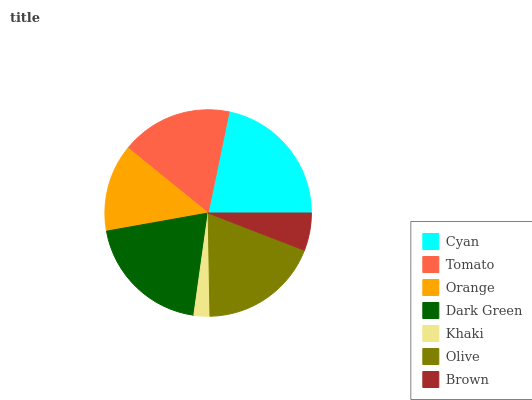Is Khaki the minimum?
Answer yes or no. Yes. Is Cyan the maximum?
Answer yes or no. Yes. Is Tomato the minimum?
Answer yes or no. No. Is Tomato the maximum?
Answer yes or no. No. Is Cyan greater than Tomato?
Answer yes or no. Yes. Is Tomato less than Cyan?
Answer yes or no. Yes. Is Tomato greater than Cyan?
Answer yes or no. No. Is Cyan less than Tomato?
Answer yes or no. No. Is Tomato the high median?
Answer yes or no. Yes. Is Tomato the low median?
Answer yes or no. Yes. Is Dark Green the high median?
Answer yes or no. No. Is Khaki the low median?
Answer yes or no. No. 